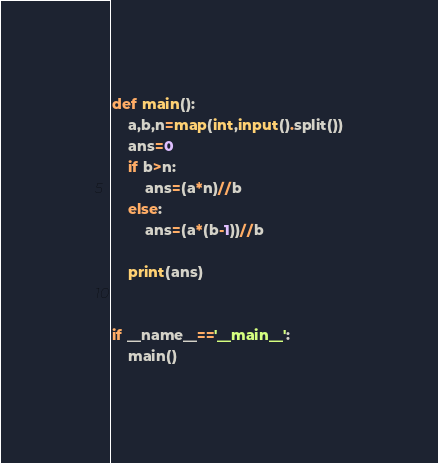<code> <loc_0><loc_0><loc_500><loc_500><_Python_>def main():
    a,b,n=map(int,input().split())
    ans=0
    if b>n:
        ans=(a*n)//b
    else:
        ans=(a*(b-1))//b
    
    print(ans)
    

if __name__=='__main__':
    main()</code> 